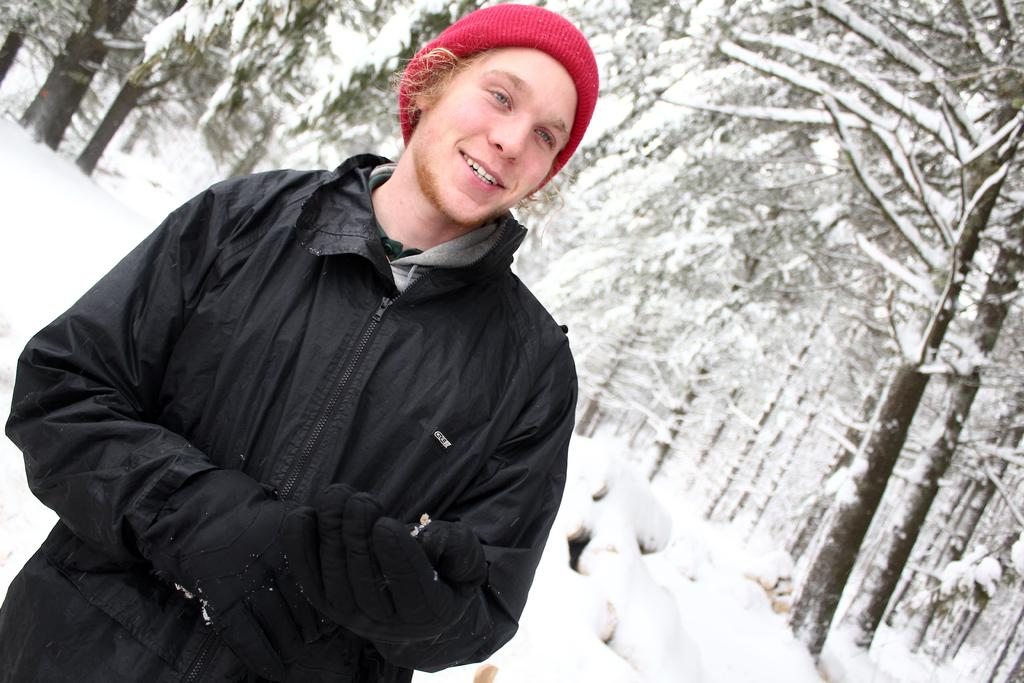What is the man in the image doing? The man is standing in the image. What is the man wearing on his head? The man is wearing a cap. What is the man wearing on his hands? The man is wearing gloves. What is present on the ground in the image? There is ice on the ground in the image. What type of vegetation can be seen in the image? There are trees in the image. What is present on the trees in the image? There is ice on the trees in the image. What type of box is the man sitting on in the image? There is no box present in the image, and the man is standing, not sitting. What type of throne is the man sitting on in the image? There is no throne present in the image, and the man is standing, not sitting. 